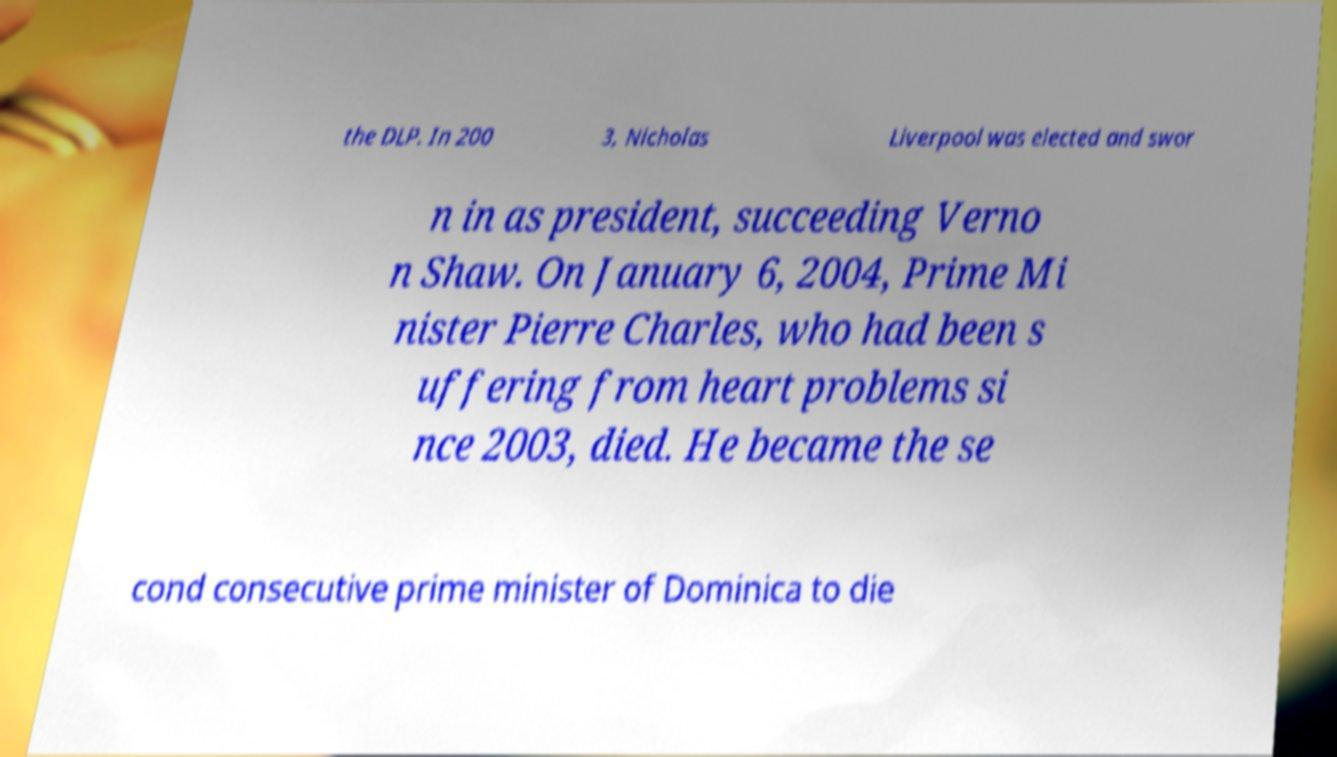Please identify and transcribe the text found in this image. the DLP. In 200 3, Nicholas Liverpool was elected and swor n in as president, succeeding Verno n Shaw. On January 6, 2004, Prime Mi nister Pierre Charles, who had been s uffering from heart problems si nce 2003, died. He became the se cond consecutive prime minister of Dominica to die 